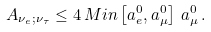Convert formula to latex. <formula><loc_0><loc_0><loc_500><loc_500>A _ { \nu _ { e } ; \nu _ { \tau } } \leq 4 \, M i n \left [ a _ { e } ^ { 0 } , a _ { \mu } ^ { 0 } \right ] \, a _ { \mu } ^ { 0 } \, .</formula> 